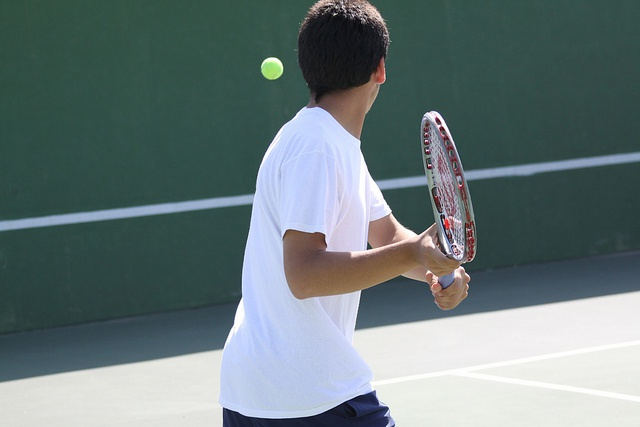Describe the objects in this image and their specific colors. I can see people in teal, lavender, black, and gray tones, tennis racket in teal, darkgray, gray, and maroon tones, and sports ball in teal, lightgreen, and ivory tones in this image. 